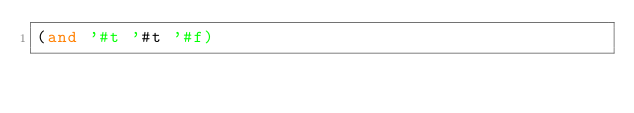<code> <loc_0><loc_0><loc_500><loc_500><_Scheme_>(and '#t '#t '#f)
</code> 